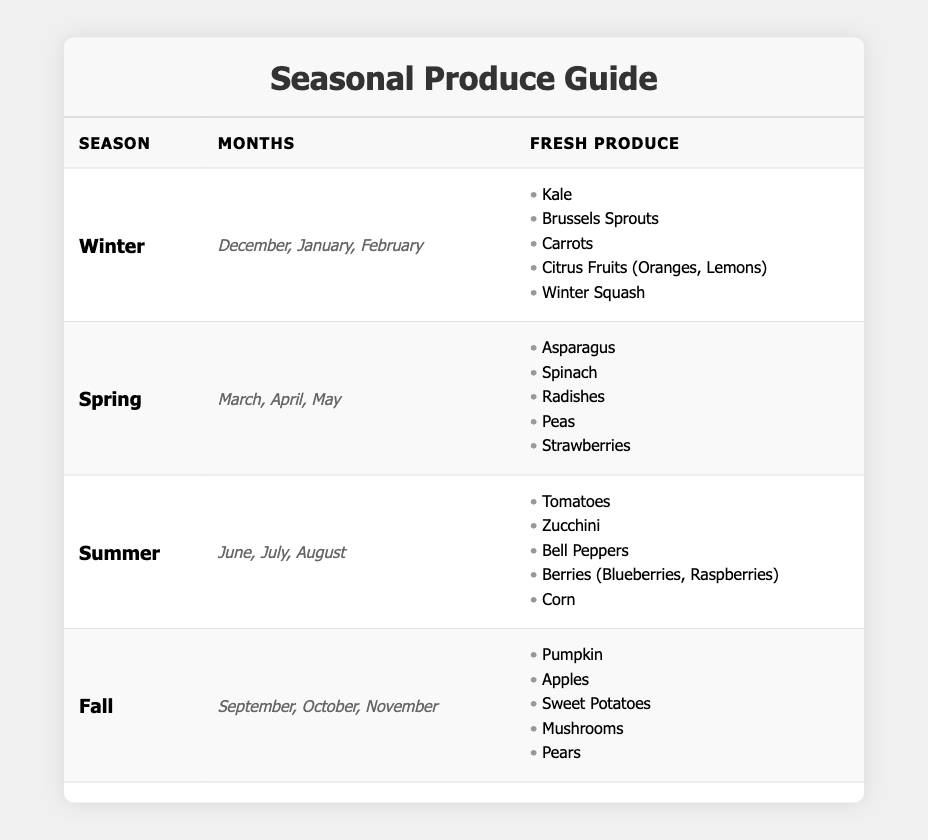What fresh produce is available in Winter? According to the table, the fresh produce available in Winter includes Kale, Brussels Sprouts, Carrots, Citrus Fruits (Oranges, Lemons), and Winter Squash.
Answer: Kale, Brussels Sprouts, Carrots, Citrus Fruits (Oranges, Lemons), Winter Squash In which months is Asparagus available? The table indicates that Asparagus is available in the Spring months of March, April, and May.
Answer: March, April, May How many types of fresh produce are listed for Summer? The Summer season includes five types of fresh produce: Tomatoes, Zucchini, Bell Peppers, Berries (Blueberries, Raspberries), and Corn.
Answer: 5 Are Mushrooms available in the Winter? The table shows that Mushrooms are listed under the Fall season; therefore, they are not available in Winter.
Answer: No Which season has the highest number of types of produce? By counting the number of fresh produce types listed, each season has five. Thus, there is no single season with the highest number, as all have an equal count.
Answer: All seasons have 5 types If I want to eat seasonal produce in August, which options do I have? In August, the available seasonal produce is from Summer, which includes Tomatoes, Zucchini, Bell Peppers, Berries (Blueberries, Raspberries), and Corn.
Answer: Tomatoes, Zucchini, Bell Peppers, Berries (Blueberries, Raspberries), Corn What is the difference in the number of fresh produce between Spring and Fall? Both Spring and Fall list five types of produce each. Therefore, the difference in the number of types of fresh produce between these two seasons is zero.
Answer: 0 Is there any overlap of fresh produce between Fall and Winter? The table does not list any overlapping produce between Fall and Winter, as each season has distinct items.
Answer: No Which season features Citrus Fruits as part of its produce? The table indicates that Citrus Fruits (Oranges, Lemons) are part of the fresh produce for Winter, specifically in the months of December, January, and February.
Answer: Winter What fruits can be eaten in both Spring and Fall? Referring to the table, no fruits are listed that are available in both Spring and Fall seasons; thus, there are no overlapping fruits.
Answer: None 